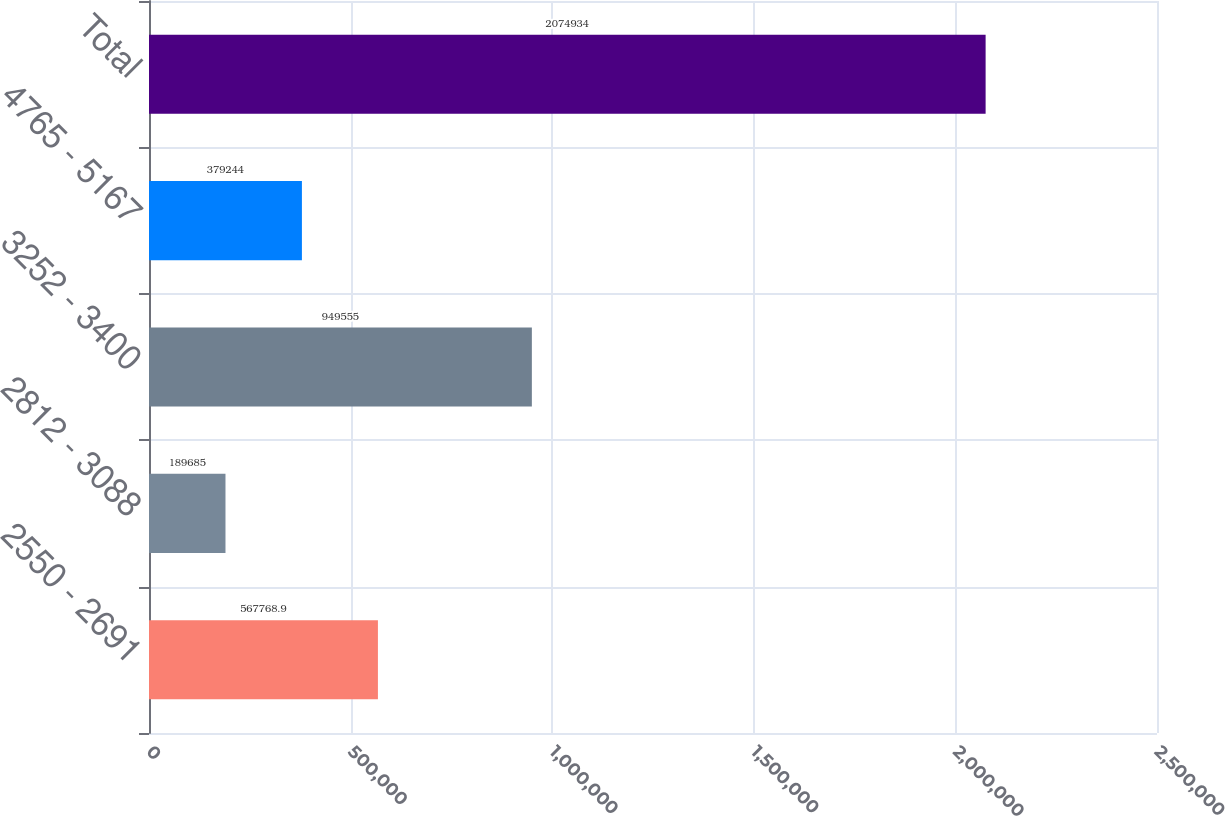Convert chart to OTSL. <chart><loc_0><loc_0><loc_500><loc_500><bar_chart><fcel>2550 - 2691<fcel>2812 - 3088<fcel>3252 - 3400<fcel>4765 - 5167<fcel>Total<nl><fcel>567769<fcel>189685<fcel>949555<fcel>379244<fcel>2.07493e+06<nl></chart> 